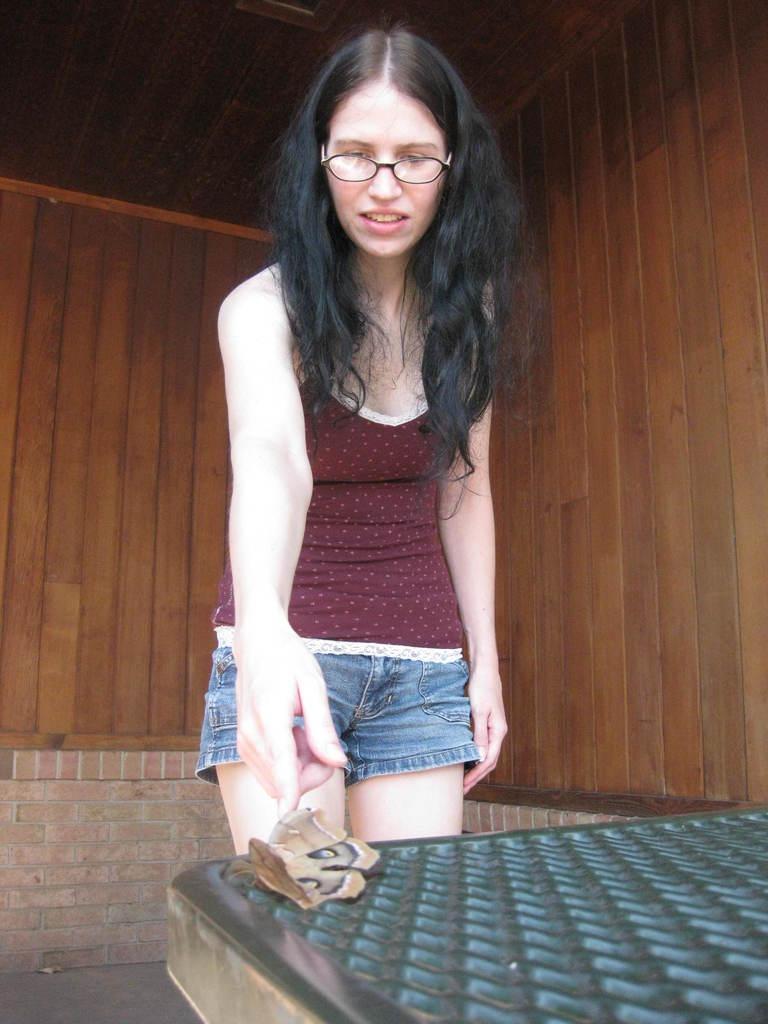Can you describe this image briefly? In this picture we can see a woman is standing on the floor and in front of the woman there is an insect on an object. Behind the woman there is a wooden wall. 